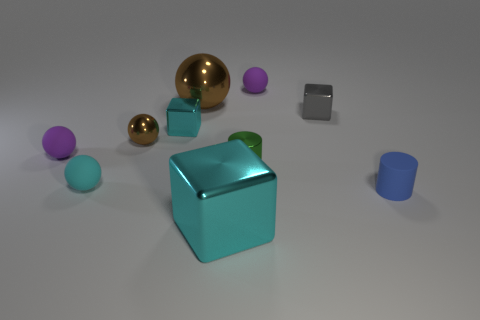How many balls are either tiny gray objects or green metallic objects?
Keep it short and to the point. 0. How many blue cylinders have the same material as the big cyan cube?
Your answer should be very brief. 0. Does the small ball behind the gray shiny thing have the same material as the cyan cube behind the large metal cube?
Ensure brevity in your answer.  No. How many small blue matte objects are on the left side of the tiny purple rubber ball that is to the left of the sphere that is on the right side of the tiny green cylinder?
Provide a short and direct response. 0. There is a matte ball on the right side of the big brown shiny object; does it have the same color as the small object on the left side of the cyan matte sphere?
Make the answer very short. Yes. Is there any other thing that is the same color as the metal cylinder?
Offer a terse response. No. The small cylinder that is left of the tiny purple rubber sphere that is right of the large cyan object is what color?
Your answer should be very brief. Green. Are there any gray metallic blocks?
Make the answer very short. Yes. What color is the tiny rubber object that is right of the small brown object and in front of the big ball?
Offer a very short reply. Blue. There is a block that is in front of the matte cylinder; is its size the same as the shiny sphere that is behind the tiny brown object?
Provide a succinct answer. Yes. 